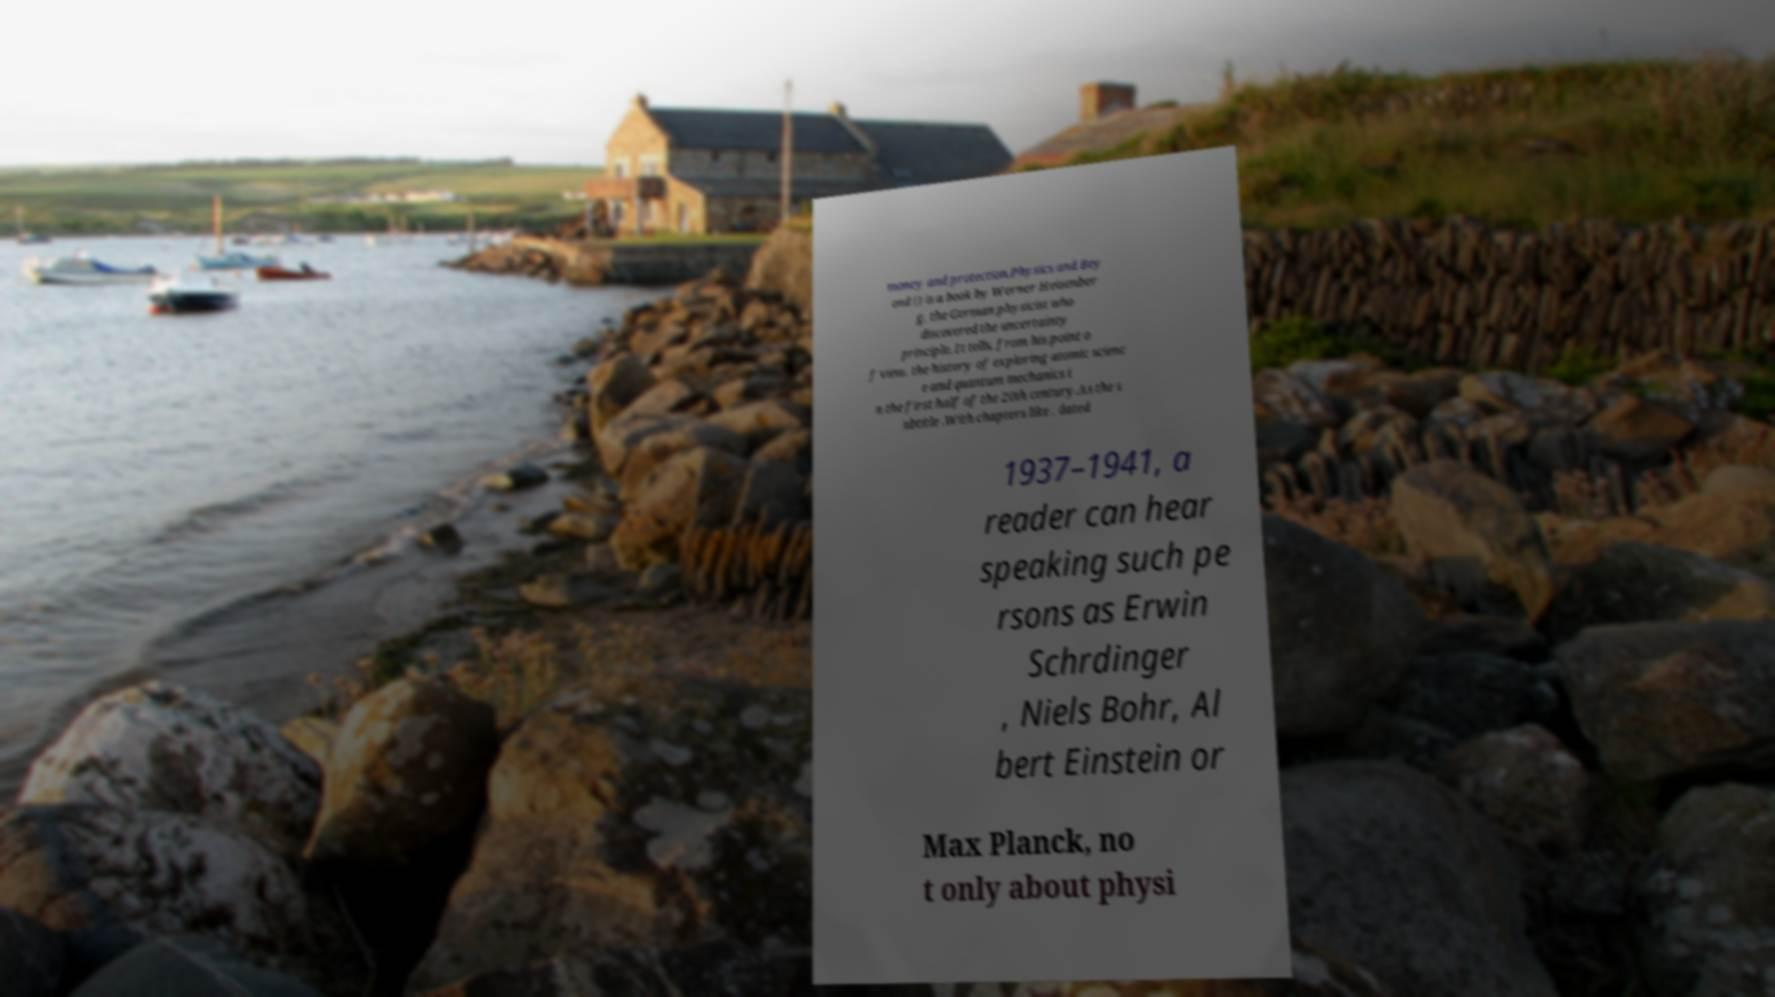Please identify and transcribe the text found in this image. money and protection.Physics and Bey ond () is a book by Werner Heisenber g, the German physicist who discovered the uncertainty principle. It tells, from his point o f view, the history of exploring atomic scienc e and quantum mechanics i n the first half of the 20th century.As the s ubtitle .With chapters like , dated 1937–1941, a reader can hear speaking such pe rsons as Erwin Schrdinger , Niels Bohr, Al bert Einstein or Max Planck, no t only about physi 